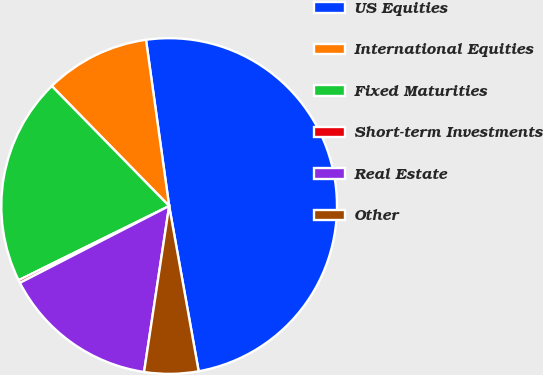Convert chart. <chart><loc_0><loc_0><loc_500><loc_500><pie_chart><fcel>US Equities<fcel>International Equities<fcel>Fixed Maturities<fcel>Short-term Investments<fcel>Real Estate<fcel>Other<nl><fcel>49.38%<fcel>10.12%<fcel>19.96%<fcel>0.28%<fcel>15.04%<fcel>5.2%<nl></chart> 